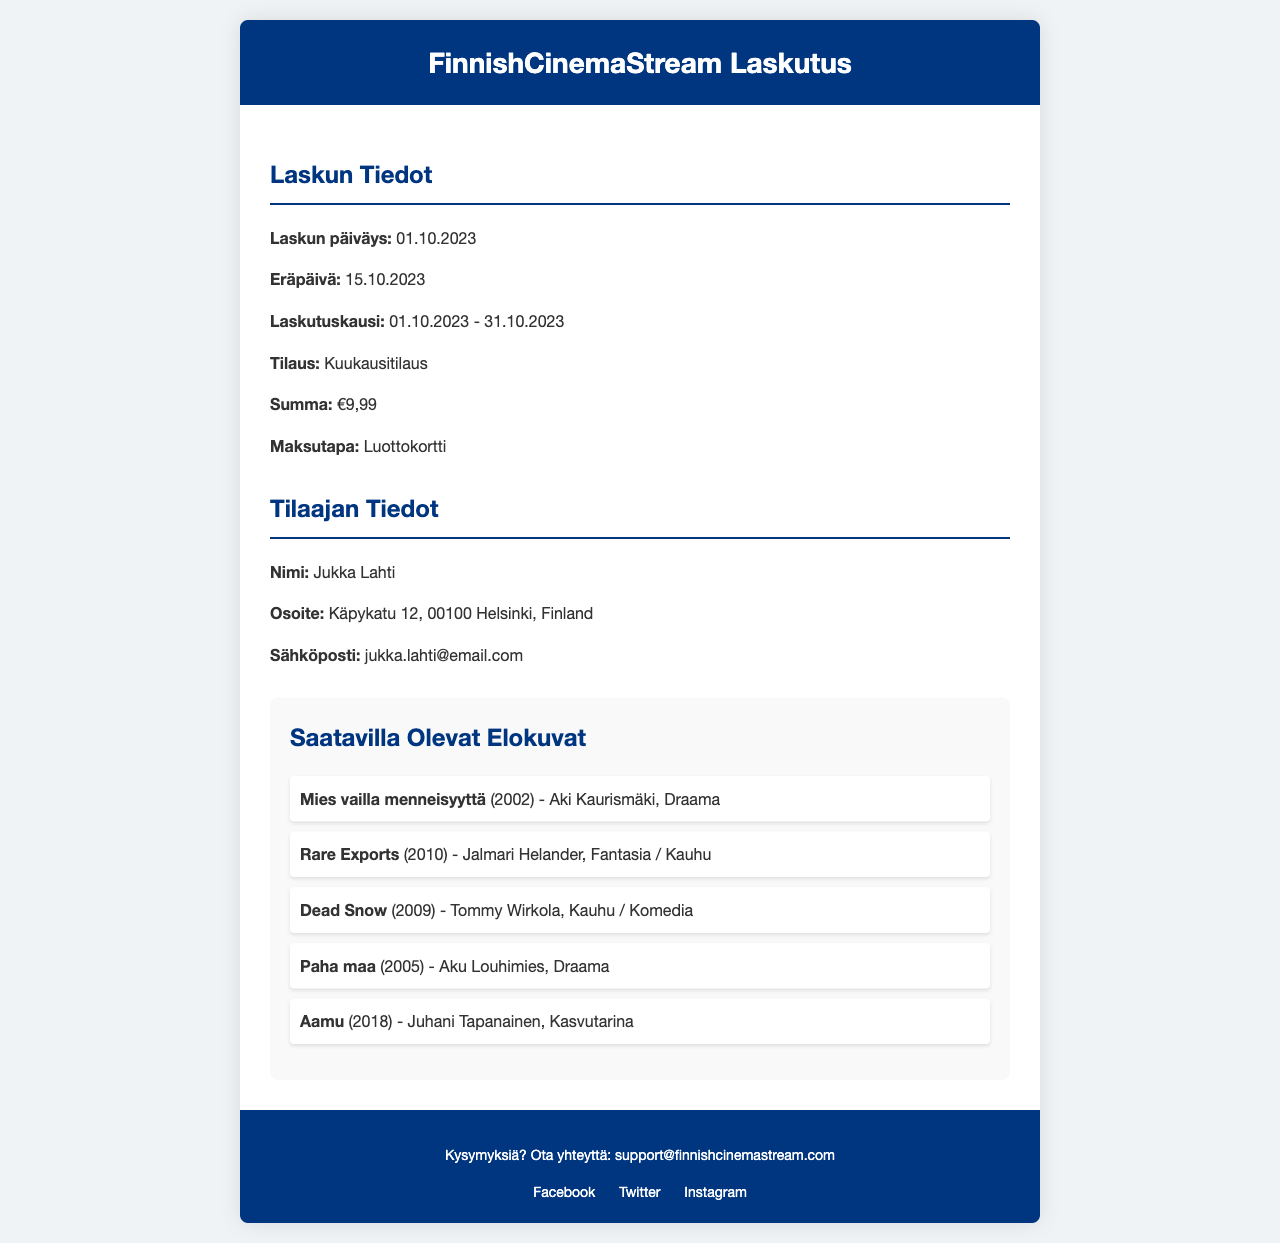what is the invoice date? The invoice date is mentioned at the beginning of the document under "Laskun Tiedot" as 01.10.2023.
Answer: 01.10.2023 what is the due date for payment? The due date is indicated in the document as 15.10.2023 under "Eräpäivä".
Answer: 15.10.2023 what is the billing period for this invoice? The billing period can be found in "Laskutuskausi" which states it is from 01.10.2023 to 31.10.2023.
Answer: 01.10.2023 - 31.10.2023 how much is the subscription fee? The subscription fee is listed under "Summa" in the invoice, showing the amount of €9,99.
Answer: €9,99 who is the subscriber? The subscriber's name is found in "Tilaajan Tiedot" as Jukka Lahti.
Answer: Jukka Lahti what method of payment is used? The payment method is specified in the document under "Maksutapa" as Luottokortti.
Answer: Luottokortti how many movies are listed in the available titles? The number of movies can be counted in the "Saatavilla Olevat Elokuvat" section, which lists five titles.
Answer: 5 which movie was made in 2002? The movie made in 2002 is mentioned in the titles list as "Mies vailla menneisyyttä".
Answer: Mies vailla menneisyyttä what genre is "Rare Exports"? The genre of "Rare Exports" is listed in the titles section as Fantasia / Kauhu.
Answer: Fantasia / Kauhu 